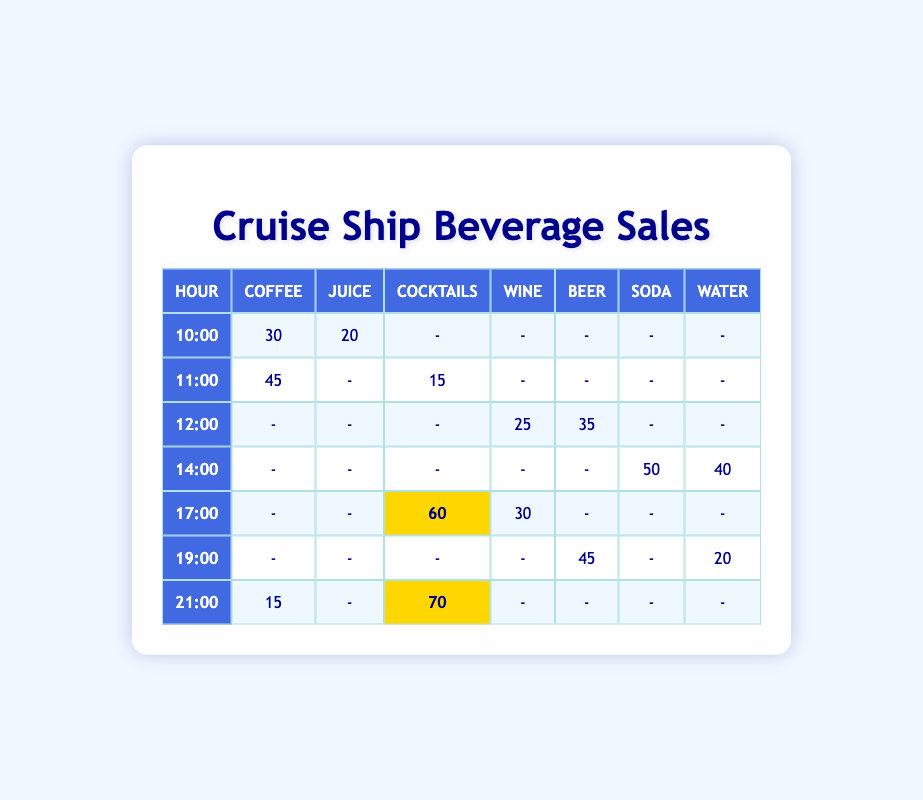What are the total sales of Coffee during the hours of service? To find the total sales of Coffee, we look at each row in the table where Coffee is listed. The sales are 30 at 10:00 and 45 at 11:00, and 15 at 21:00. Adding these amounts gives us 30 + 45 + 15 = 90.
Answer: 90 Which beverage had the highest sales at 21:00? Looking at the row for 21:00, the sales figures for Cocktails, Coffee, Wine, Beer, Soda, and Water are 70, 15, -, -, -, and -. The highest value is 70 for Cocktails.
Answer: Cocktails Is the sales of Beer higher at 12:00 or 19:00? At 12:00, the sales of Beer is 35. At 19:00, the sales of Beer is 45. Since 45 is greater than 35, the sales of Beer is higher at 19:00.
Answer: Yes What is the total number of sales for Water and Soda combined at 14:00? At 14:00, the sales for Soda is 50 and for Water is 40. To find the total, we add these two amounts together: 50 + 40 = 90.
Answer: 90 Was the sales of Cocktails ever below 20 during the service hours? Reviewing the table, the sales of Cocktails are 15 at 11:00, which is below 20. Thus, the statement is true.
Answer: Yes What is the average sales of Wine across all service hours? The Wine sales figures are 25 at 12:00 and 30 at 17:00. Summing these gives us 25 + 30 = 55. There are 2 entries, so the average is 55 / 2 = 27.5.
Answer: 27.5 At which hour was Soda sold the most? The Soda sales is recorded only at 14:00, with a total of 50. There are no other entries for Soda, so 50 at 14:00 is the highest sales.
Answer: 14:00 How many beverages had sales recorded for 14:00? For 14:00, the table shows sales figures for Soda which is 50 and Water which is 40. Thus, there are 2 different beverages with sales recorded during this hour.
Answer: 2 